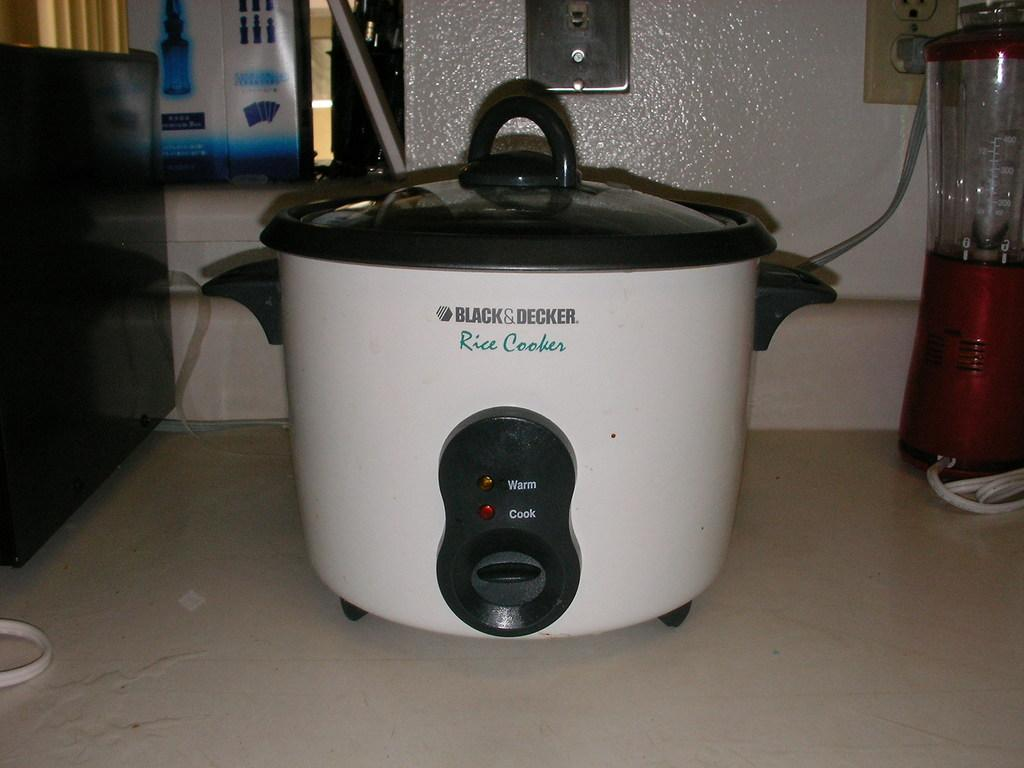<image>
Provide a brief description of the given image. a crock pot with black and decker on it 